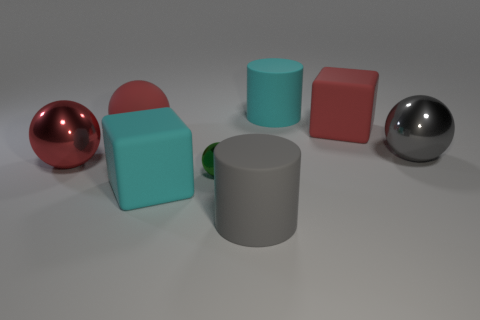Subtract all big gray spheres. How many spheres are left? 3 Subtract all red spheres. How many spheres are left? 2 Subtract 0 green cubes. How many objects are left? 8 Subtract all blocks. How many objects are left? 6 Subtract 1 spheres. How many spheres are left? 3 Subtract all gray cylinders. Subtract all purple spheres. How many cylinders are left? 1 Subtract all cyan cubes. How many yellow cylinders are left? 0 Subtract all big red metallic spheres. Subtract all large cyan rubber cylinders. How many objects are left? 6 Add 8 big cyan matte blocks. How many big cyan matte blocks are left? 9 Add 7 big gray rubber objects. How many big gray rubber objects exist? 8 